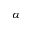Convert formula to latex. <formula><loc_0><loc_0><loc_500><loc_500>\alpha</formula> 